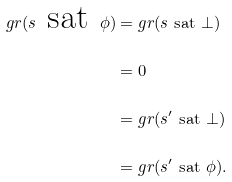Convert formula to latex. <formula><loc_0><loc_0><loc_500><loc_500>g r ( s \ \text {sat} \ \phi ) & = g r ( s \ \text {sat} \ \bot ) \\ & = 0 \\ & = g r ( s ^ { \prime } \ \text {sat} \ \bot ) \\ & = g r ( s ^ { \prime } \ \text {sat} \ \phi ) .</formula> 